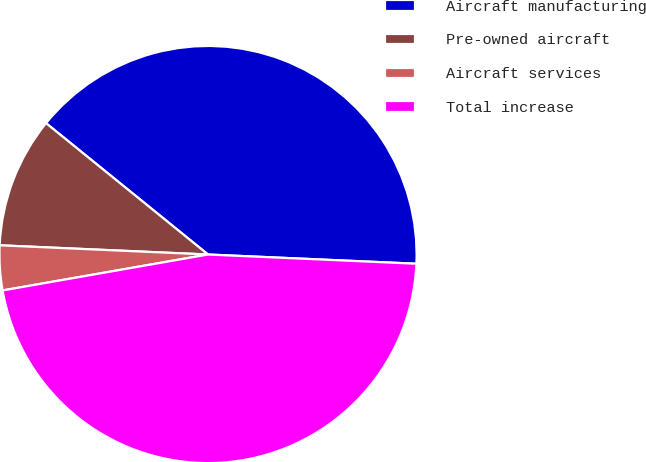Convert chart to OTSL. <chart><loc_0><loc_0><loc_500><loc_500><pie_chart><fcel>Aircraft manufacturing<fcel>Pre-owned aircraft<fcel>Aircraft services<fcel>Total increase<nl><fcel>39.86%<fcel>10.14%<fcel>3.46%<fcel>46.54%<nl></chart> 